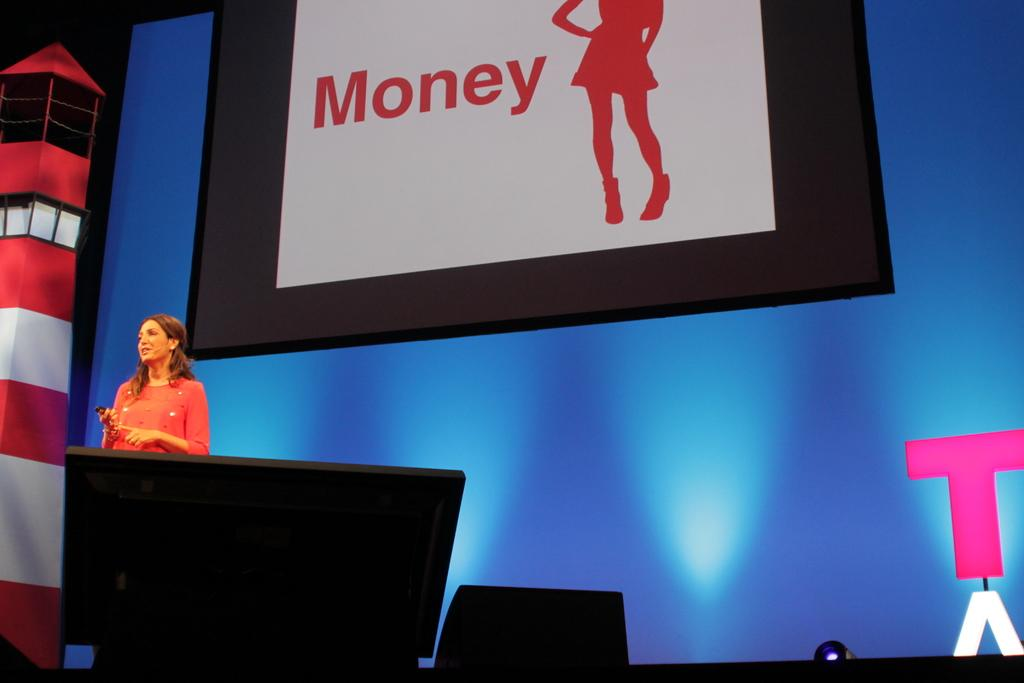<image>
Present a compact description of the photo's key features. A woman is speaking on a stage the word Money on the screen behind her. 